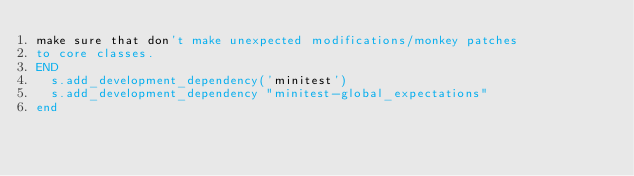<code> <loc_0><loc_0><loc_500><loc_500><_Ruby_>make sure that don't make unexpected modifications/monkey patches
to core classes.
END
  s.add_development_dependency('minitest')
  s.add_development_dependency "minitest-global_expectations"
end
</code> 